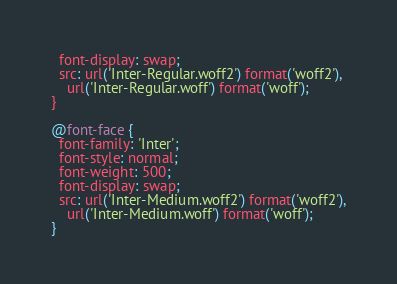Convert code to text. <code><loc_0><loc_0><loc_500><loc_500><_CSS_>  font-display: swap;
  src: url('Inter-Regular.woff2') format('woff2'),
    url('Inter-Regular.woff') format('woff');
}

@font-face {
  font-family: 'Inter';
  font-style: normal;
  font-weight: 500;
  font-display: swap;
  src: url('Inter-Medium.woff2') format('woff2'),
    url('Inter-Medium.woff') format('woff');
}
</code> 